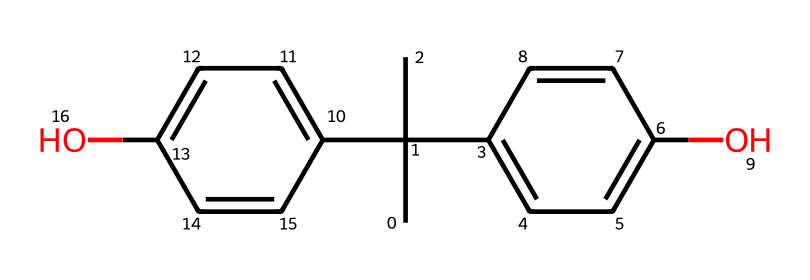how many carbon atoms are in this chemical structure? By analyzing the SMILES representation, we can count the 'C' characters, which represent carbon atoms. There are a total of 15 'C' symbols present in the notation.
Answer: 15 what are the functional groups present in this chemical? The chemical structure contains hydroxyl groups (-OH) attached to aromatic rings, as indicated by the 'O' within the structure. These are the primary functional groups identified.
Answer: hydroxyl groups is this chemical aromatic? The presence of alternating double bonds in the rings (identified by the pattern in the SMILES) indicates that it contains aromatic rings, hence it is classified as aromatic.
Answer: yes how many rings are found in the structure? By examining the SMILES notation, we see that there are two instances of 'C=C', which indicates the presence of two interconnected cyclic structures, confirming the existence of two rings.
Answer: 2 does this chemical undergo polymerization? Bisphenol A has functional groups reactive in polymerization, particularly useful in forming polycarbonate and epoxy resins, confirming its potential to undergo polymerization.
Answer: yes what type of polymer is formed from this chemical? Bisphenol A is typically used to form polycarbonate and epoxy polymers through polymerization reactions, making these types of polymers associated with it.
Answer: polycarbonate and epoxy what physical state is this chemical at room temperature? As a small organic compound, bisphenol A is solid at room temperature, generally appearing as a crystalline solid, indicating its physical state.
Answer: solid 